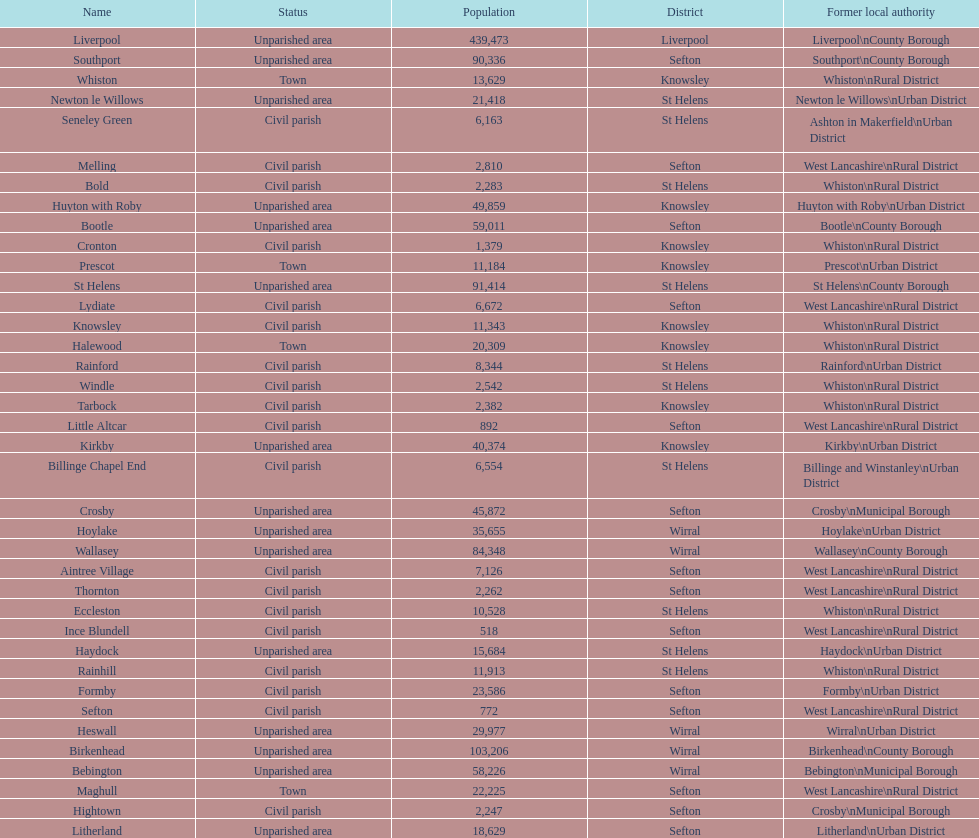Which is a civil parish, aintree village or maghull? Aintree Village. 